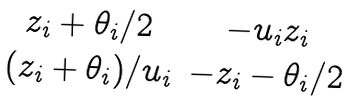Convert formula to latex. <formula><loc_0><loc_0><loc_500><loc_500>\begin{matrix} z _ { i } + \theta _ { i } / 2 & - u _ { i } z _ { i } \\ ( z _ { i } + \theta _ { i } ) / u _ { i } & - z _ { i } - \theta _ { i } / 2 \end{matrix}</formula> 